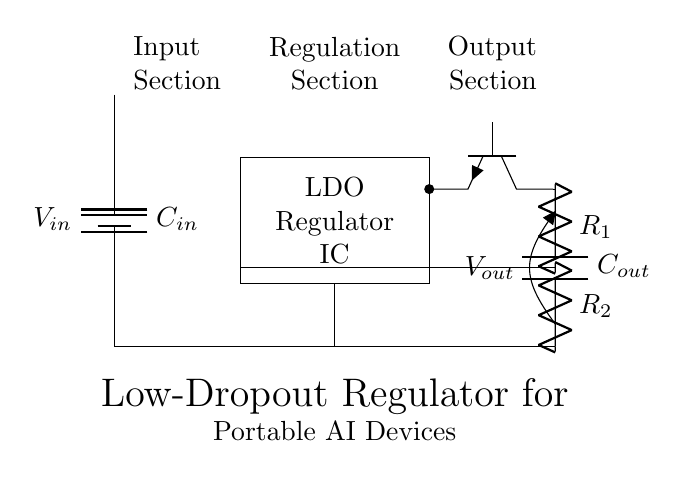What is the input voltage of this circuit? The input voltage is indicated at the battery symbol, labeled as V_{in}.
Answer: V_{in} What does the acronym LDO stand for in this circuit? LDO stands for Low-Dropout, which is a type of voltage regulator that can maintain its output voltage with a small difference between input and output voltages.
Answer: Low-Dropout How many feedback resistors are present in the circuit? There are two feedback resistors labeled as R_1 and R_2 connected in the feedback path.
Answer: 2 Identify the function of C_{out} in the circuit. C_{out} is the output capacitor, which is used to stabilize the output voltage and improve transient response.
Answer: Stabilization What is the primary role of the pass transistor in this low-dropout regulator? The pass transistor, labeled as Tnpn, controls the output current and regulates the voltage drop from the input to the output effectively.
Answer: Regulation How does the feedback loop influence the output voltage? The feedback loop connects the output voltage back to the LDO to ensure that any changes in output are corrected by adjusting the output current, maintaining a steady voltage.
Answer: Regulation 